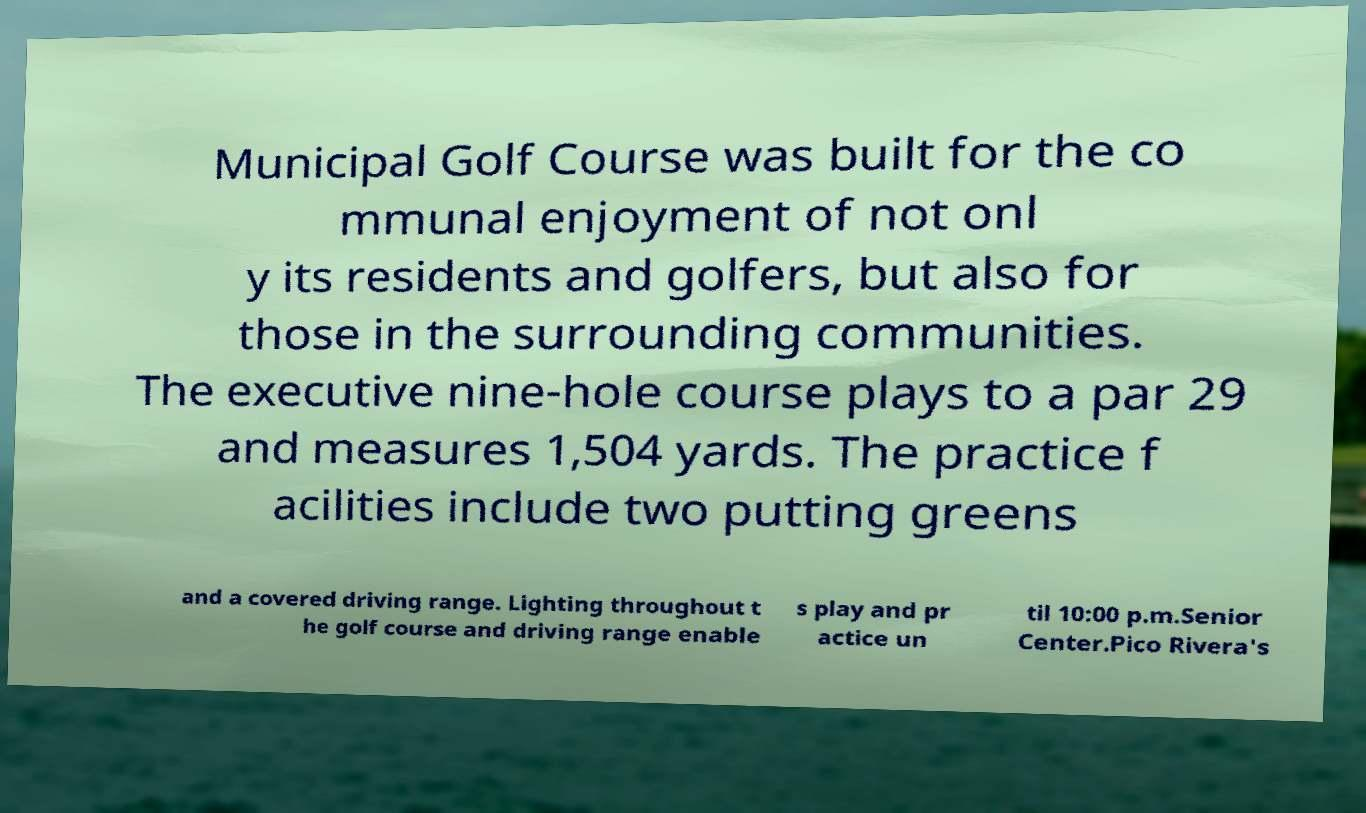I need the written content from this picture converted into text. Can you do that? Municipal Golf Course was built for the co mmunal enjoyment of not onl y its residents and golfers, but also for those in the surrounding communities. The executive nine-hole course plays to a par 29 and measures 1,504 yards. The practice f acilities include two putting greens and a covered driving range. Lighting throughout t he golf course and driving range enable s play and pr actice un til 10:00 p.m.Senior Center.Pico Rivera's 